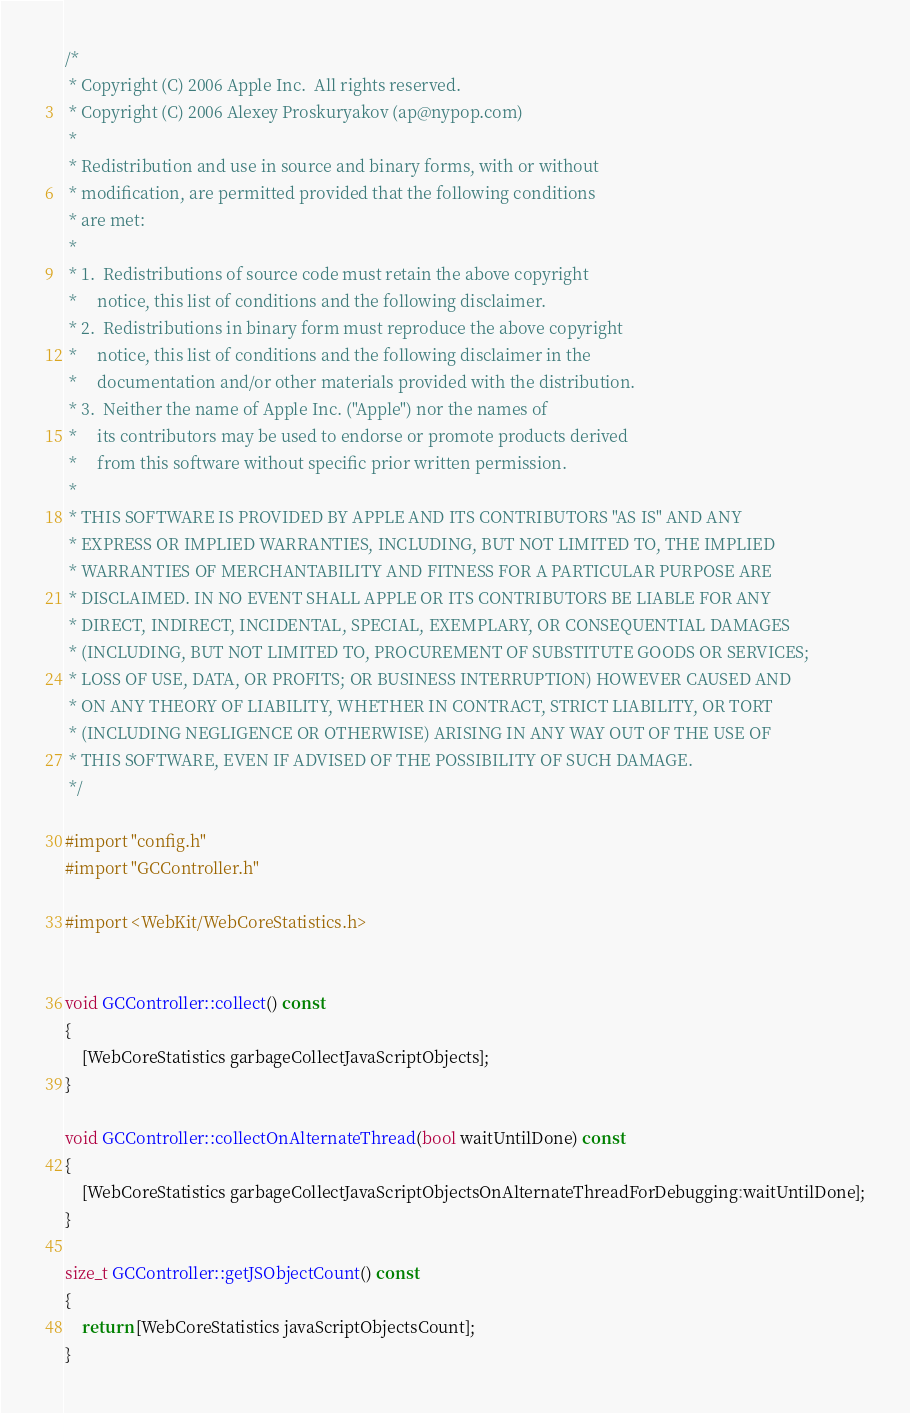Convert code to text. <code><loc_0><loc_0><loc_500><loc_500><_ObjectiveC_>/*
 * Copyright (C) 2006 Apple Inc.  All rights reserved.
 * Copyright (C) 2006 Alexey Proskuryakov (ap@nypop.com)
 *
 * Redistribution and use in source and binary forms, with or without
 * modification, are permitted provided that the following conditions
 * are met:
 *
 * 1.  Redistributions of source code must retain the above copyright
 *     notice, this list of conditions and the following disclaimer. 
 * 2.  Redistributions in binary form must reproduce the above copyright
 *     notice, this list of conditions and the following disclaimer in the
 *     documentation and/or other materials provided with the distribution. 
 * 3.  Neither the name of Apple Inc. ("Apple") nor the names of
 *     its contributors may be used to endorse or promote products derived
 *     from this software without specific prior written permission. 
 *
 * THIS SOFTWARE IS PROVIDED BY APPLE AND ITS CONTRIBUTORS "AS IS" AND ANY
 * EXPRESS OR IMPLIED WARRANTIES, INCLUDING, BUT NOT LIMITED TO, THE IMPLIED
 * WARRANTIES OF MERCHANTABILITY AND FITNESS FOR A PARTICULAR PURPOSE ARE
 * DISCLAIMED. IN NO EVENT SHALL APPLE OR ITS CONTRIBUTORS BE LIABLE FOR ANY
 * DIRECT, INDIRECT, INCIDENTAL, SPECIAL, EXEMPLARY, OR CONSEQUENTIAL DAMAGES
 * (INCLUDING, BUT NOT LIMITED TO, PROCUREMENT OF SUBSTITUTE GOODS OR SERVICES;
 * LOSS OF USE, DATA, OR PROFITS; OR BUSINESS INTERRUPTION) HOWEVER CAUSED AND
 * ON ANY THEORY OF LIABILITY, WHETHER IN CONTRACT, STRICT LIABILITY, OR TORT
 * (INCLUDING NEGLIGENCE OR OTHERWISE) ARISING IN ANY WAY OUT OF THE USE OF
 * THIS SOFTWARE, EVEN IF ADVISED OF THE POSSIBILITY OF SUCH DAMAGE.
 */

#import "config.h"
#import "GCController.h"

#import <WebKit/WebCoreStatistics.h>


void GCController::collect() const
{
    [WebCoreStatistics garbageCollectJavaScriptObjects];
}

void GCController::collectOnAlternateThread(bool waitUntilDone) const
{
    [WebCoreStatistics garbageCollectJavaScriptObjectsOnAlternateThreadForDebugging:waitUntilDone];
}

size_t GCController::getJSObjectCount() const
{
    return [WebCoreStatistics javaScriptObjectsCount];
}
</code> 